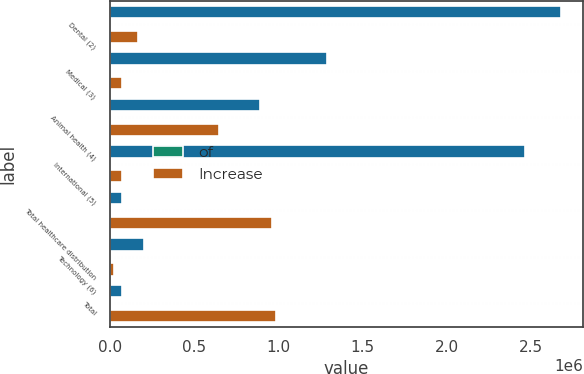<chart> <loc_0><loc_0><loc_500><loc_500><stacked_bar_chart><ecel><fcel>Dental (2)<fcel>Medical (3)<fcel>Animal health (4)<fcel>International (5)<fcel>Total healthcare distribution<fcel>Technology (6)<fcel>Total<nl><fcel>nan<fcel>2.67883e+06<fcel>1.29043e+06<fcel>889303<fcel>2.46828e+06<fcel>73408<fcel>199952<fcel>73408<nl><fcel>of<fcel>35.6<fcel>17.1<fcel>11.8<fcel>32.8<fcel>97.3<fcel>2.7<fcel>100<nl><fcel>Increase<fcel>168909<fcel>73408<fcel>649221<fcel>70172<fcel>961710<fcel>26744<fcel>988454<nl></chart> 